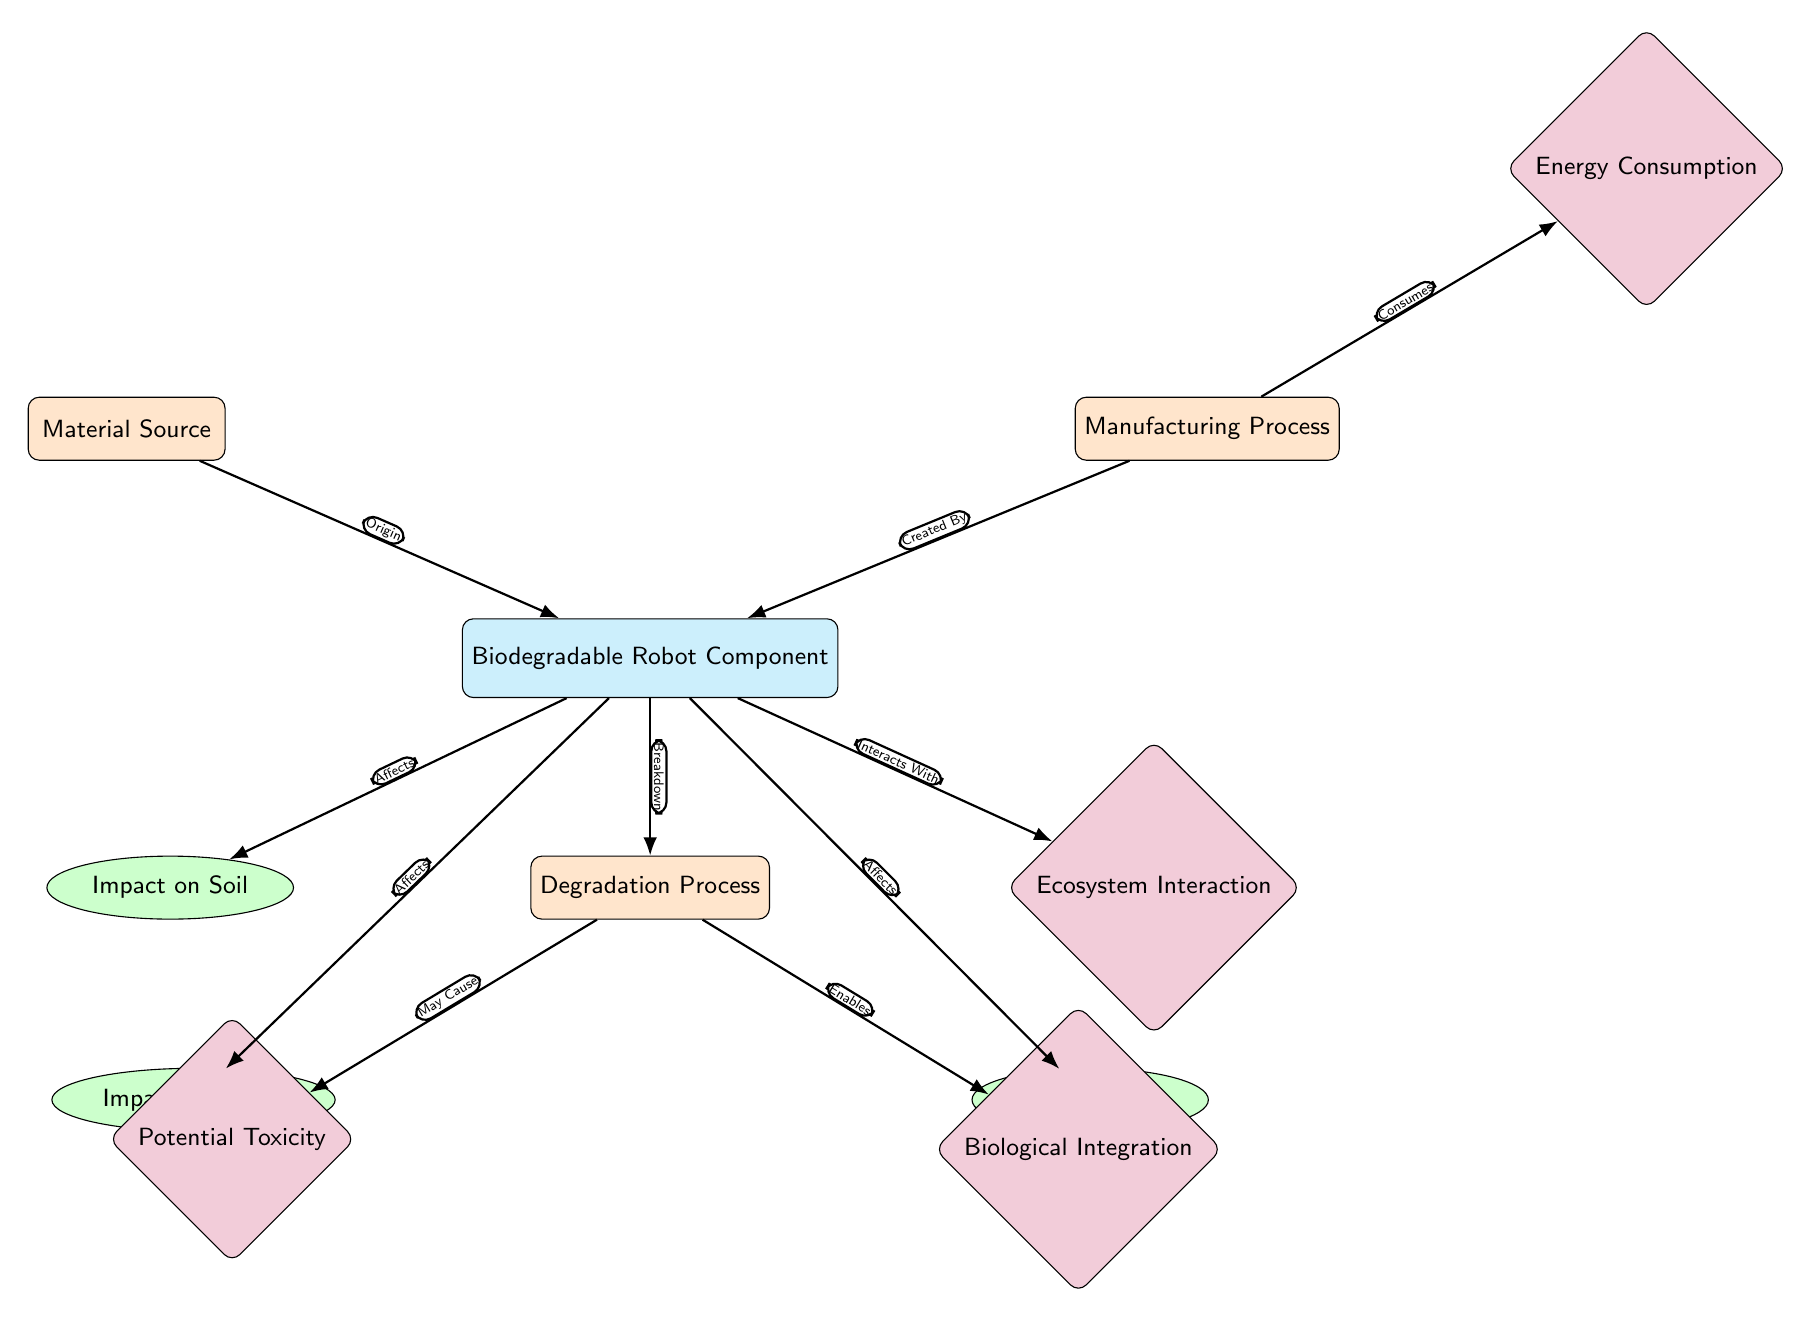What is the main component illustrated in the diagram? The diagram illustrates the "Biodegradable Robot Component" as the main focus, highlighted in the center of the diagram.
Answer: Biodegradable Robot Component How many impact nodes are present in the diagram? There are three impact nodes shown: "Impact on Soil," "Impact on Water," and "Impact on Air." Counting these nodes leads to a total of three.
Answer: 3 What affects the air according to the diagram? The diagram specifies that the "Biodegradable Robot Component" affects the air, indicated by the edge labeled "Affects" leading to the "Impact on Air" node.
Answer: Biodegradable Robot Component Which process consumes energy according to the diagram? The "Manufacturing Process" is the process that consumes energy, as depicted by the edge labeled "Consumes" connecting it to the "Energy Consumption" node.
Answer: Manufacturing Process What may cause potential toxicity? The diagram indicates that the "Degradation Process" may cause potential toxicity, as shown by the edge labeled "May Cause" leading to the "Potential Toxicity" node.
Answer: Degradation Process How does the biodegradable robot component interact with the ecosystem? The diagram shows that the "Biodegradable Robot Component" interacts with the ecosystem, indicated by the edge labeled "Interacts With" connecting to the "Ecosystem Interaction" node.
Answer: Interacts With What is the relationship between the manufacturing process and energy consumption? The relationship is that the manufacturing process consumes energy; this is shown by the "Consumes" edge connecting the manufacturing process node to the energy consumption node.
Answer: Consumes What enables biological integration? Biological integration is enabled by the degradation process, as represented by the edge labeled "Enables" leading to the "Biological Integration" node from the "Degradation Process."
Answer: Degradation Process What relationships are shown between the biodegradable robot component and the water? The diagram shows that the biodegradable robot component affects water, depicted by the edge labeled "Affects" that connects to the "Impact on Water" node.
Answer: Affects 